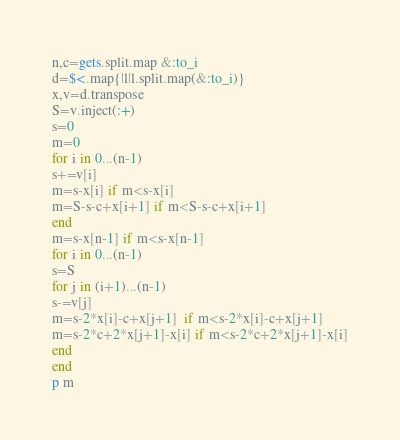<code> <loc_0><loc_0><loc_500><loc_500><_Ruby_>n,c=gets.split.map &:to_i
d=$<.map{|l|l.split.map(&:to_i)}
x,v=d.transpose
S=v.inject(:+)
s=0
m=0
for i in 0...(n-1)
s+=v[i]
m=s-x[i] if m<s-x[i]
m=S-s-c+x[i+1] if m<S-s-c+x[i+1]
end
m=s-x[n-1] if m<s-x[n-1]
for i in 0...(n-1)
s=S
for j in (i+1)...(n-1)
s-=v[j]
m=s-2*x[i]-c+x[j+1]  if m<s-2*x[i]-c+x[j+1]
m=s-2*c+2*x[j+1]-x[i] if m<s-2*c+2*x[j+1]-x[i]
end
end
p m</code> 